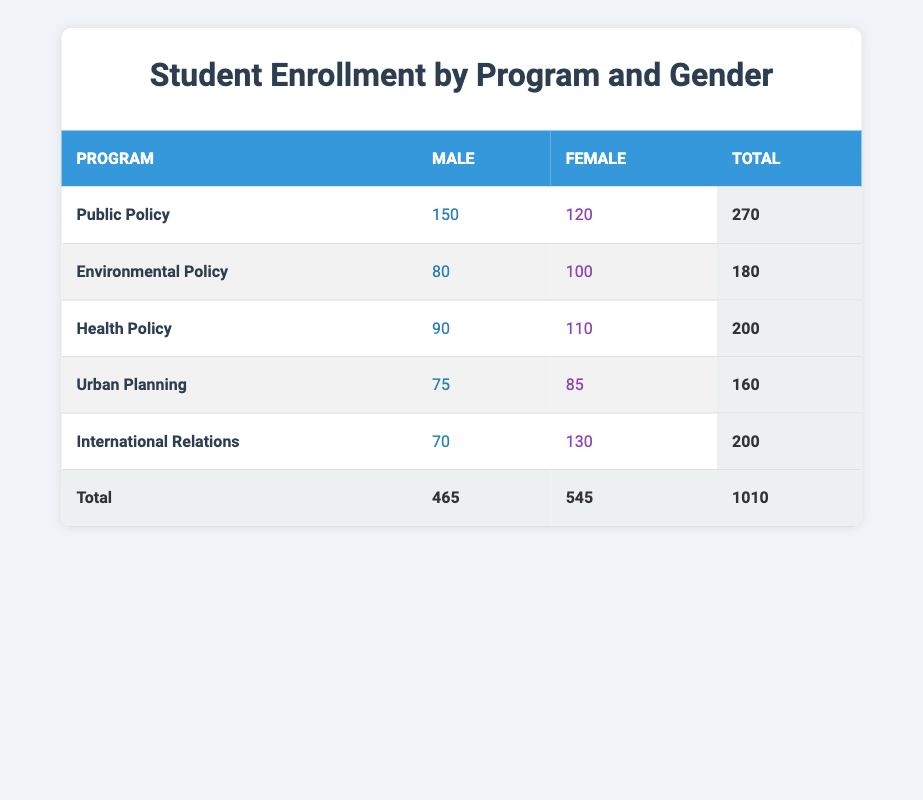What is the total number of male students enrolled in Health Policy? In the table for the Health Policy program, the number of male students is directly listed as 90.
Answer: 90 How many female students are enrolled in Urban Planning? The table shows that there are 85 female students in the Urban Planning program.
Answer: 85 Which program has the highest total enrollment? To find the program with the highest total enrollment, we check the total column: Public Policy has 270, Environmental Policy has 180, Health Policy has 200, Urban Planning has 160, and International Relations has 200. Public Policy has the highest total of 270.
Answer: Public Policy How many more female students than male students are enrolled in International Relations? The International Relations data shows 70 male and 130 female students. The difference is 130 - 70 = 60.
Answer: 60 What is the overall ratio of male to female students across all programs? There are 465 male students and 545 female students in total. The ratio can be calculated as 465:545, which simplifies to about 93:109 after dividing both numbers by 5.
Answer: 93:109 Is there a program where female enrollment exceeds male enrollment? By examining the table, it's evident that in every program except for International Relations, female enrollment exceeds male enrollment. This can be seen with the counts: Public Policy has 120 females (greater than 150 males), Environmental Policy has 100 females (greater than 80 males), Health Policy has 110 females (greater than 90 males), and Urban Planning has 85 females (greater than 75 males). Thus, the answer is yes.
Answer: Yes Which gender has a higher total enrollment across all programs? From the totals, there are 465 male and 545 female students. Since 545 is greater than 465, female students have higher total enrollment.
Answer: Female What is the total enrollment for the Environmental Policy program? The table lists the total enrollment for Environmental Policy as the sum of male and female students: 80 male and 100 female, totaling 180.
Answer: 180 Which program has the least total number of students? By comparing the total enrollments listed in the table, Urban Planning has the least total enrollment of 160 students.
Answer: Urban Planning 